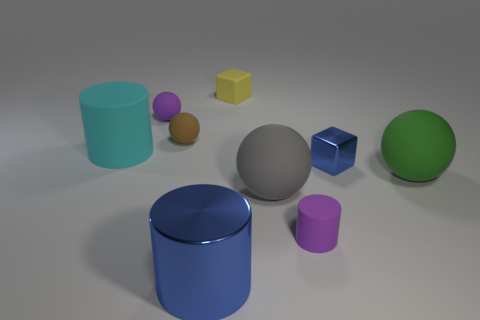Add 1 big metal cylinders. How many objects exist? 10 Subtract all spheres. How many objects are left? 5 Add 6 small purple objects. How many small purple objects are left? 8 Add 5 blue spheres. How many blue spheres exist? 5 Subtract 0 red spheres. How many objects are left? 9 Subtract all tiny yellow things. Subtract all small yellow things. How many objects are left? 7 